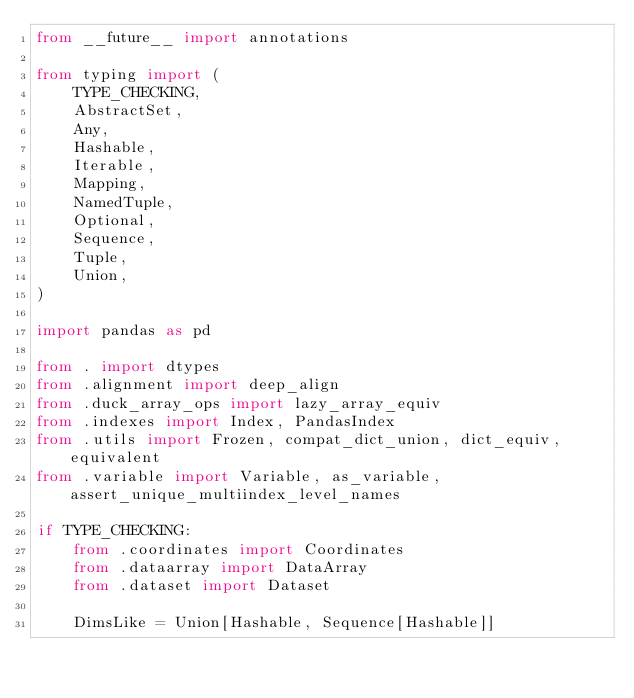<code> <loc_0><loc_0><loc_500><loc_500><_Python_>from __future__ import annotations

from typing import (
    TYPE_CHECKING,
    AbstractSet,
    Any,
    Hashable,
    Iterable,
    Mapping,
    NamedTuple,
    Optional,
    Sequence,
    Tuple,
    Union,
)

import pandas as pd

from . import dtypes
from .alignment import deep_align
from .duck_array_ops import lazy_array_equiv
from .indexes import Index, PandasIndex
from .utils import Frozen, compat_dict_union, dict_equiv, equivalent
from .variable import Variable, as_variable, assert_unique_multiindex_level_names

if TYPE_CHECKING:
    from .coordinates import Coordinates
    from .dataarray import DataArray
    from .dataset import Dataset

    DimsLike = Union[Hashable, Sequence[Hashable]]</code> 